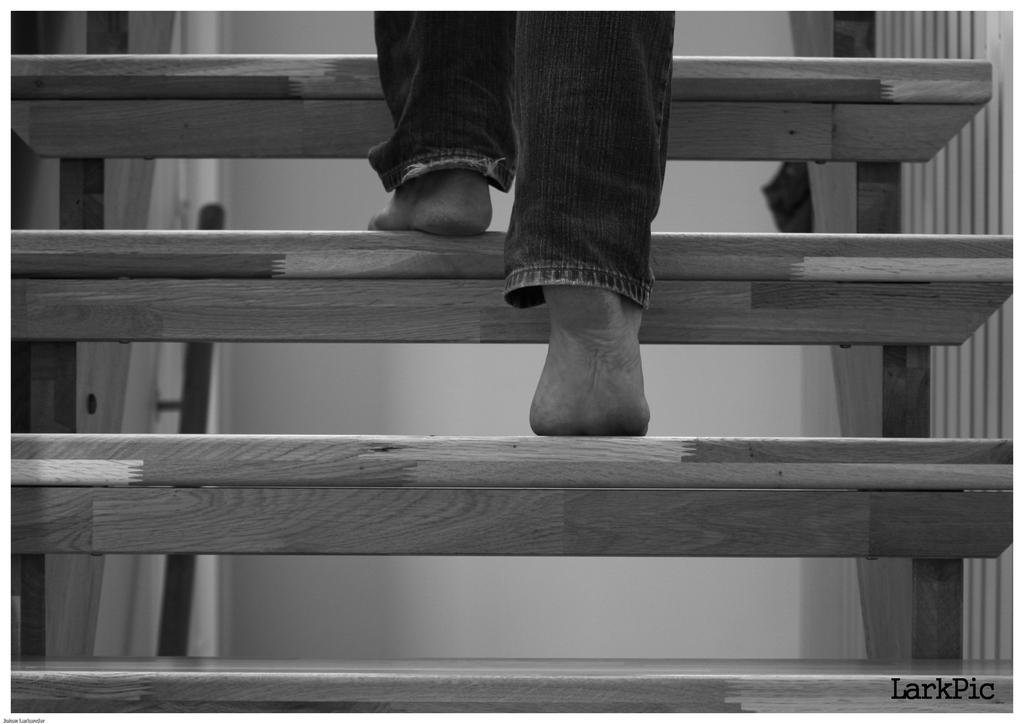What type of structure is present in the image? There are stairs in the image. Can you describe the position of the person in the image? A person's legs are visible on the stairs. What can be seen in the background of the image? There is a wall in the background of the image. What is the color scheme of the image? The image is black and white. What type of mask is the person wearing while climbing the stairs in the image? There is no mask visible in the image; the person's legs are the only part of their body that can be seen. 